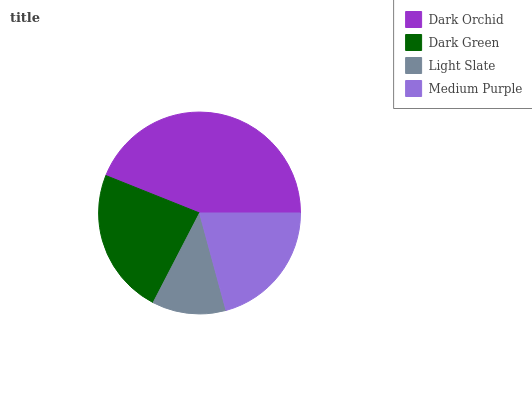Is Light Slate the minimum?
Answer yes or no. Yes. Is Dark Orchid the maximum?
Answer yes or no. Yes. Is Dark Green the minimum?
Answer yes or no. No. Is Dark Green the maximum?
Answer yes or no. No. Is Dark Orchid greater than Dark Green?
Answer yes or no. Yes. Is Dark Green less than Dark Orchid?
Answer yes or no. Yes. Is Dark Green greater than Dark Orchid?
Answer yes or no. No. Is Dark Orchid less than Dark Green?
Answer yes or no. No. Is Dark Green the high median?
Answer yes or no. Yes. Is Medium Purple the low median?
Answer yes or no. Yes. Is Light Slate the high median?
Answer yes or no. No. Is Dark Orchid the low median?
Answer yes or no. No. 